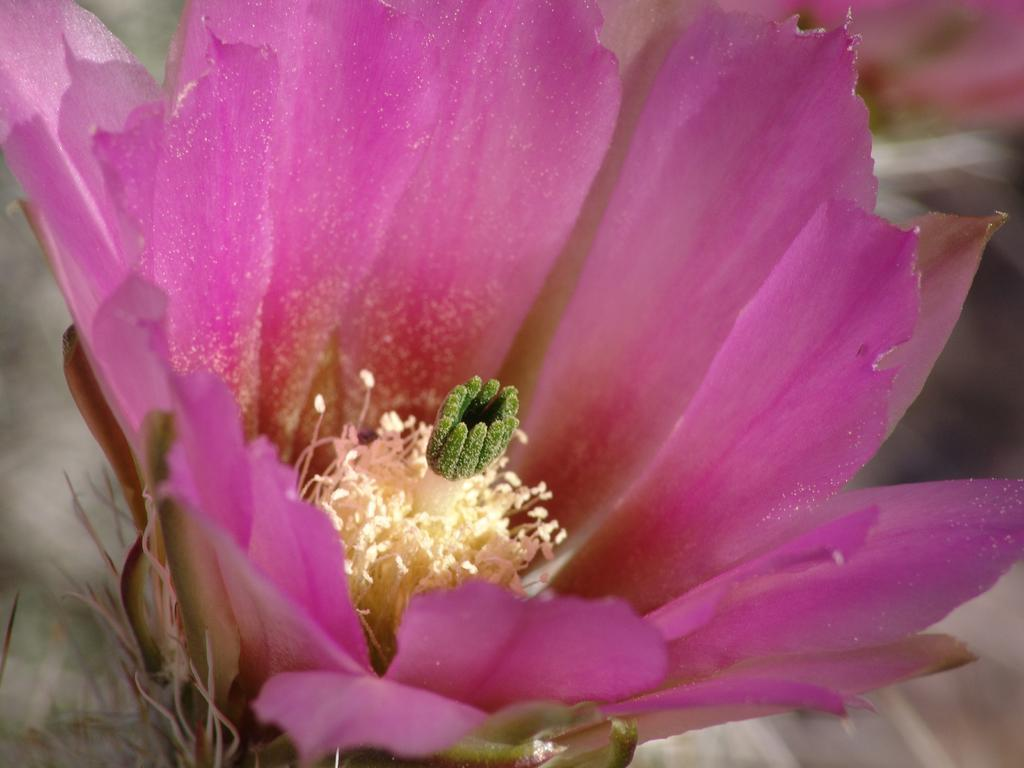What is the main subject in the foreground of the image? There is a pink color flower in the foreground of the image. What can be observed on the flower? The flower has pollen grains. What type of mask is the flower wearing in the image? A: There is no mask present on the flower in the image. Can you recite a verse that is written on the flower in the image? There is no verse written on the flower in the image. 